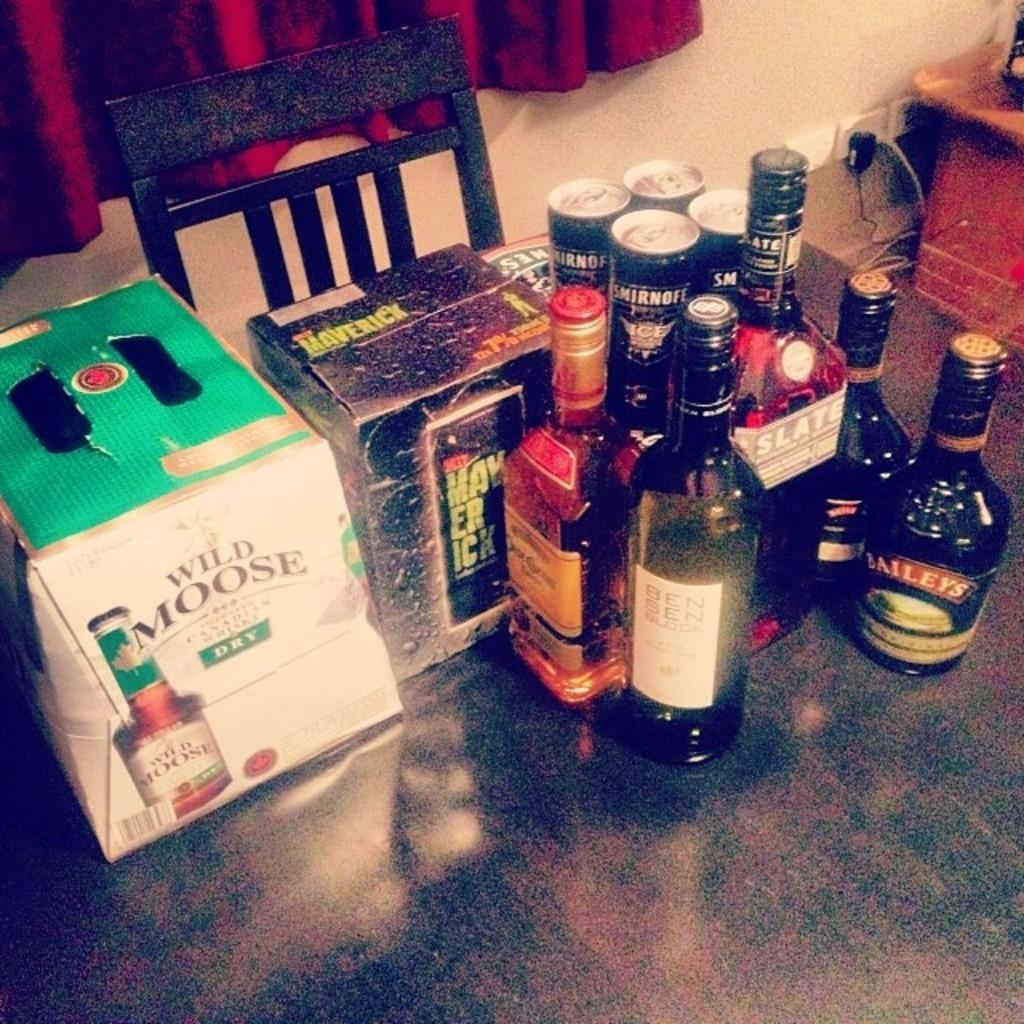<image>
Provide a brief description of the given image. A box with wild moose written upon it. 